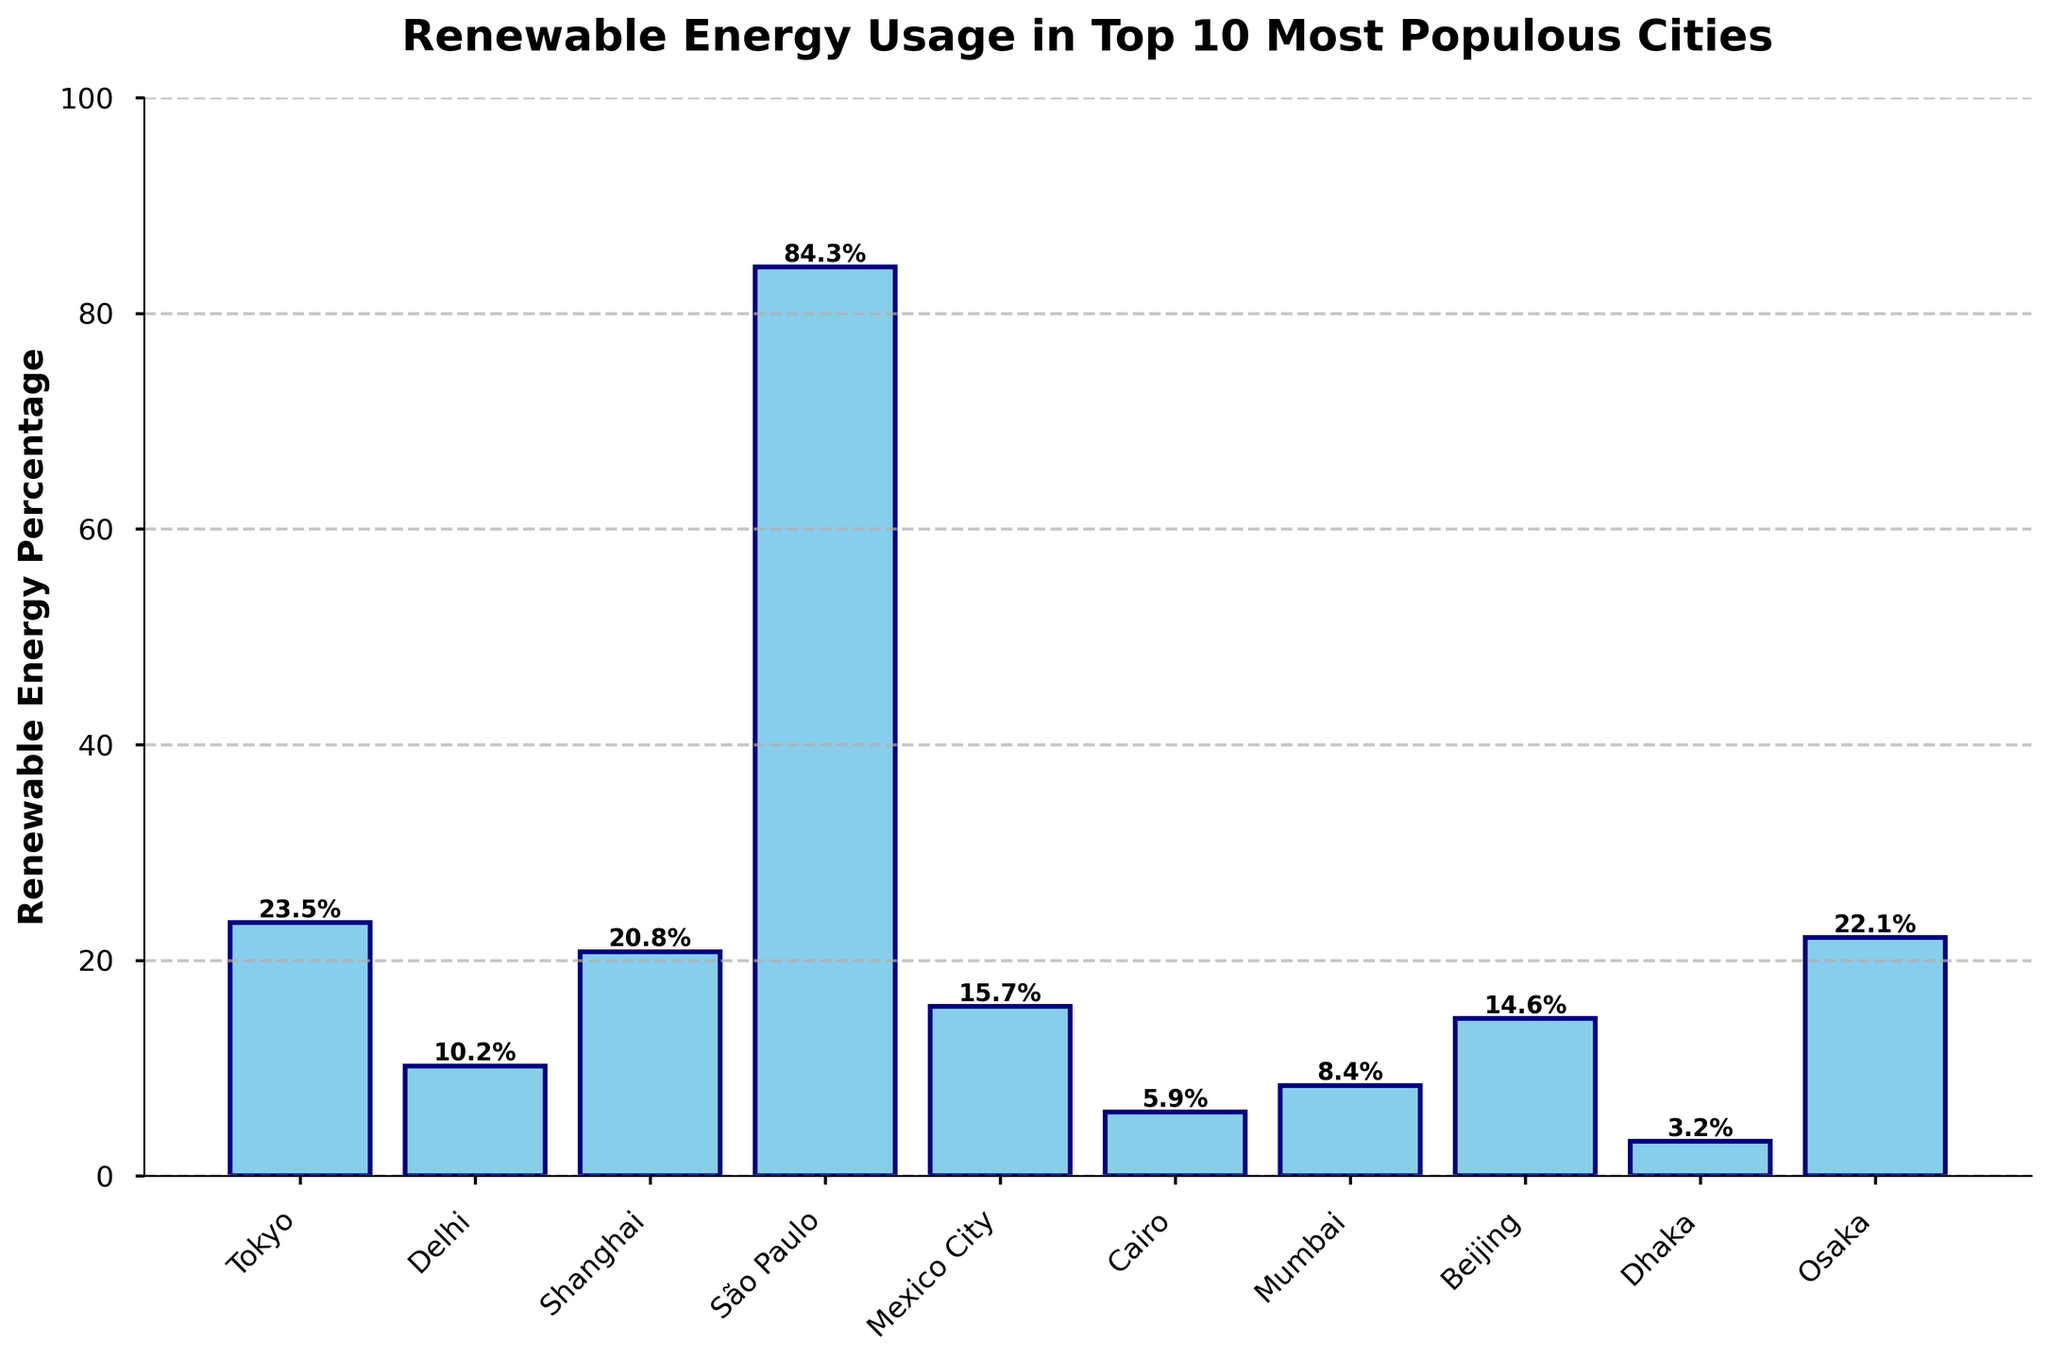What is the city with the highest percentage of renewable energy usage? The city with the highest percentage of renewable energy usage is São Paulo, which has a renewable energy percentage of 84.3%.
Answer: São Paulo Which cities have a renewable energy percentage greater than 20%? By looking at the bars higher than the 20% mark, the cities with a renewable energy percentage greater than 20% are Tokyo, Shanghai, São Paulo, and Osaka.
Answer: Tokyo, Shanghai, São Paulo, Osaka What is the difference in renewable energy usage between Dhaka and São Paulo? Dhaka has a renewable energy percentage of 3.2%, and São Paulo has 84.3%. The difference is 84.3% - 3.2% = 81.1%.
Answer: 81.1% What is the average percentage of renewable energy usage across all the cities? Add the renewable energy percentages of all cities and divide by the number of cities: (23.5 + 10.2 + 20.8 + 84.3 + 15.7 + 5.9 + 8.4 + 14.6 + 3.2 + 22.1) / 10 = 20.87%.
Answer: 20.87% How many cities have a renewable energy percentage less than 15%? The cities with renewable energy percentages less than 15% are Delhi, Mexico City, Cairo, Mumbai, Beijing, and Dhaka. There are 6 such cities.
Answer: 6 Which city has the smallest renewable energy percentage, and what is it? The city with the smallest renewable energy percentage is Dhaka, with a percentage of 3.2%.
Answer: Dhaka, 3.2% Rank the top three cities in descending order of renewable energy usage. The top three cities with the highest renewable energy usage are São Paulo (84.3%), Tokyo (23.5%), and Osaka (22.1%).
Answer: São Paulo, Tokyo, Osaka Compare the renewable energy usage between Tokyo and Beijing. Which one is higher and by how much? Tokyo has a renewable energy percentage of 23.5%, while Beijing has 14.6%. Tokyo's renewable energy usage is higher by 23.5% - 14.6% = 8.9%.
Answer: Tokyo, 8.9% What is the median renewable energy percentage of these cities? To find the median, list the percentages in ascending order: 3.2, 5.9, 8.4, 10.2, 14.6, 15.7, 20.8, 22.1, 23.5, 84.3. The median is the average of the 5th and 6th values: (14.6 + 15.7) / 2 = 15.15%.
Answer: 15.15% 